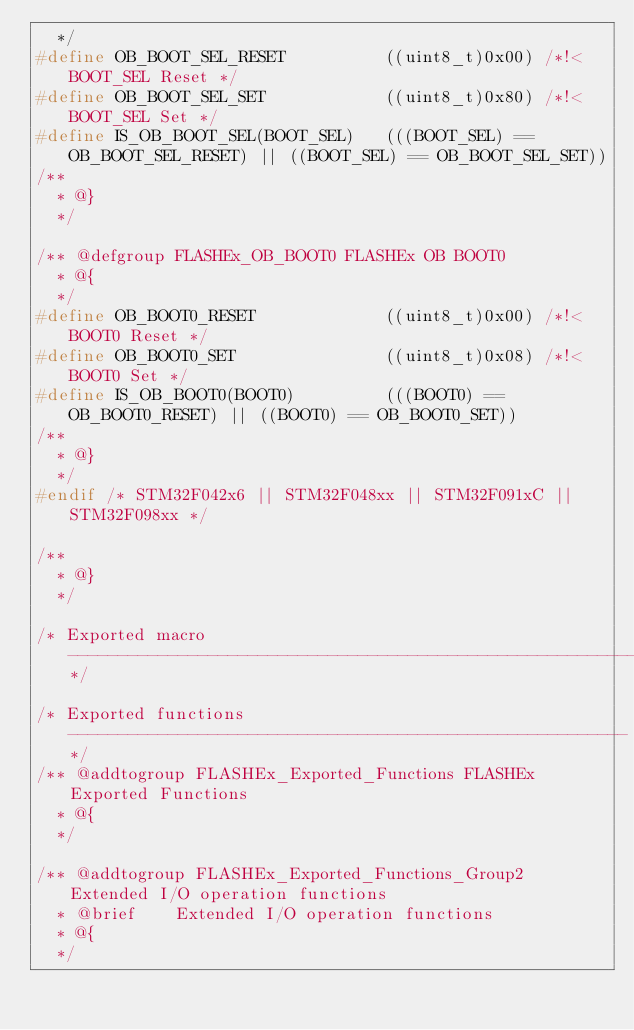Convert code to text. <code><loc_0><loc_0><loc_500><loc_500><_C_>  */
#define OB_BOOT_SEL_RESET          ((uint8_t)0x00) /*!< BOOT_SEL Reset */
#define OB_BOOT_SEL_SET            ((uint8_t)0x80) /*!< BOOT_SEL Set */
#define IS_OB_BOOT_SEL(BOOT_SEL)   (((BOOT_SEL) == OB_BOOT_SEL_RESET) || ((BOOT_SEL) == OB_BOOT_SEL_SET))
/**
  * @}
  */  

/** @defgroup FLASHEx_OB_BOOT0 FLASHEx OB BOOT0
  * @{
  */
#define OB_BOOT0_RESET             ((uint8_t)0x00) /*!< BOOT0 Reset */
#define OB_BOOT0_SET               ((uint8_t)0x08) /*!< BOOT0 Set */
#define IS_OB_BOOT0(BOOT0)         (((BOOT0) == OB_BOOT0_RESET) || ((BOOT0) == OB_BOOT0_SET))
/**
  * @}
  */  
#endif /* STM32F042x6 || STM32F048xx || STM32F091xC || STM32F098xx */

/**
  * @}
  */ 
  
/* Exported macro ------------------------------------------------------------*/

/* Exported functions --------------------------------------------------------*/
/** @addtogroup FLASHEx_Exported_Functions FLASHEx Exported Functions
  * @{
  */
  
/** @addtogroup FLASHEx_Exported_Functions_Group2 Extended I/O operation functions
  * @brief    Extended I/O operation functions
  * @{
  */   </code> 